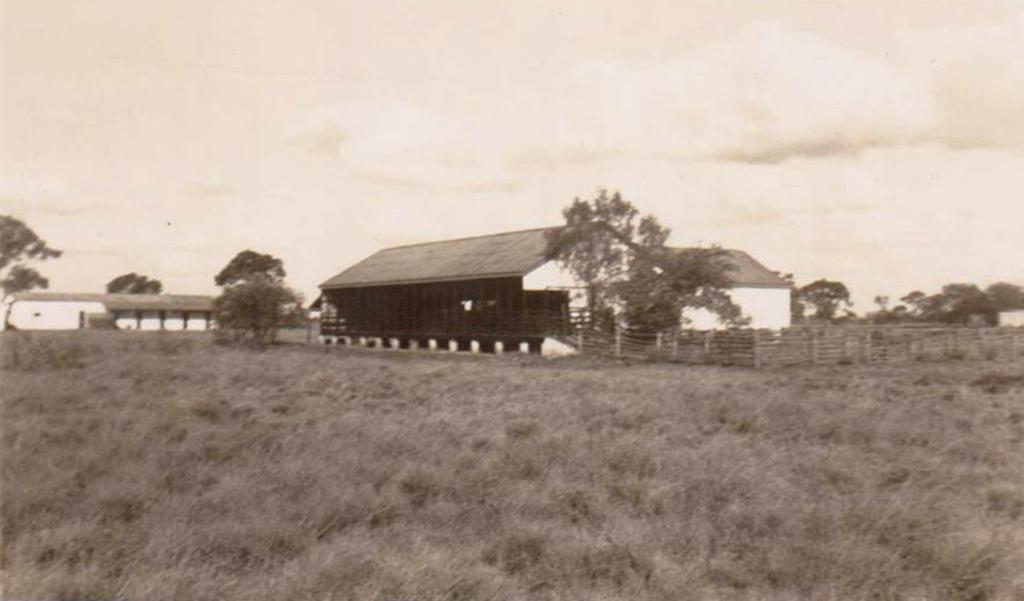Describe this image in one or two sentences. In the foreground of this black and white image, at the bottom, there is grass. In the middle, there are houses and trees. At the top, there is the sky. 